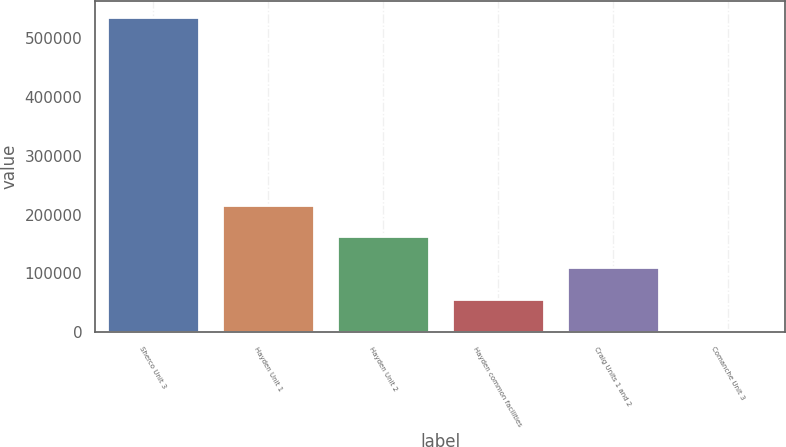<chart> <loc_0><loc_0><loc_500><loc_500><bar_chart><fcel>Sherco Unit 3<fcel>Hayden Unit 1<fcel>Hayden Unit 2<fcel>Hayden common facilities<fcel>Craig Units 1 and 2<fcel>Comanche Unit 3<nl><fcel>535643<fcel>216490<fcel>163298<fcel>56913.2<fcel>110105<fcel>3721<nl></chart> 